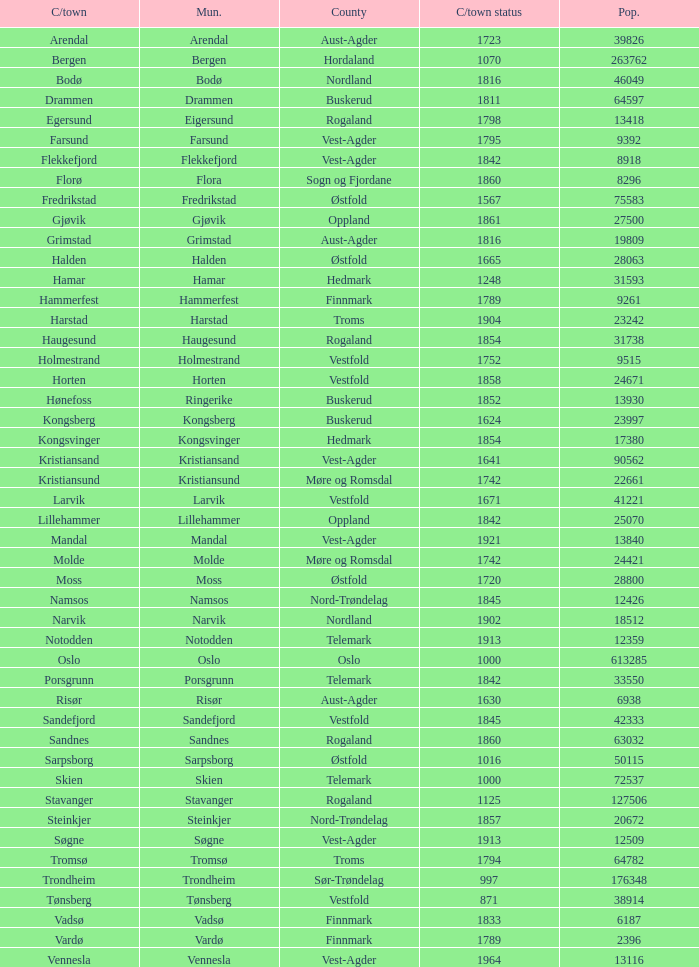Which municipalities located in the county of Finnmark have populations bigger than 6187.0? Hammerfest. 